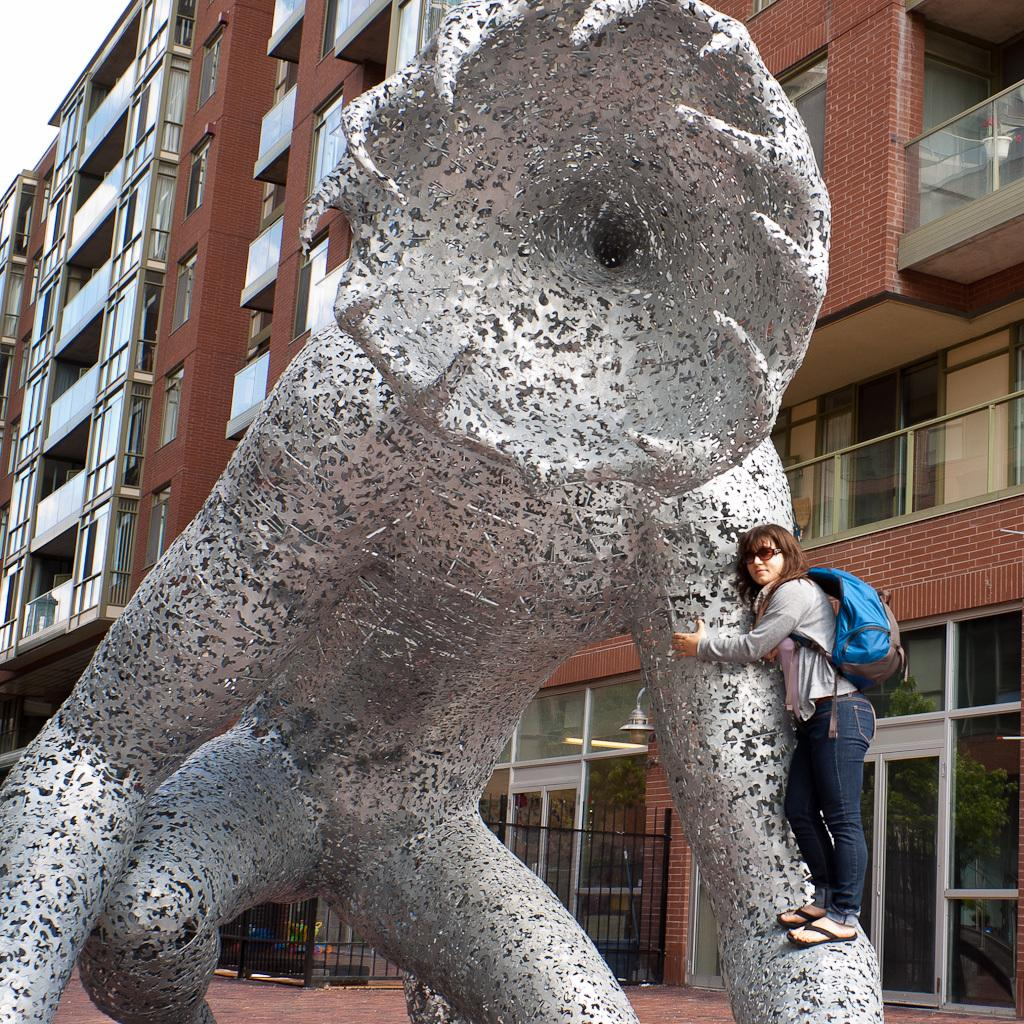Who or what is the main subject of the image? There is a person in the image. What is the person wearing in the image? The person is wearing a backpack. What is the person doing in the image? The person is standing on a statue. What can be seen in the background of the image? There are buildings visible in the image. What type of loaf is the person holding in the image? There is no loaf present in the image. Who is the owner of the statue the person is standing on in the image? The image does not provide information about the ownership of the statue. 